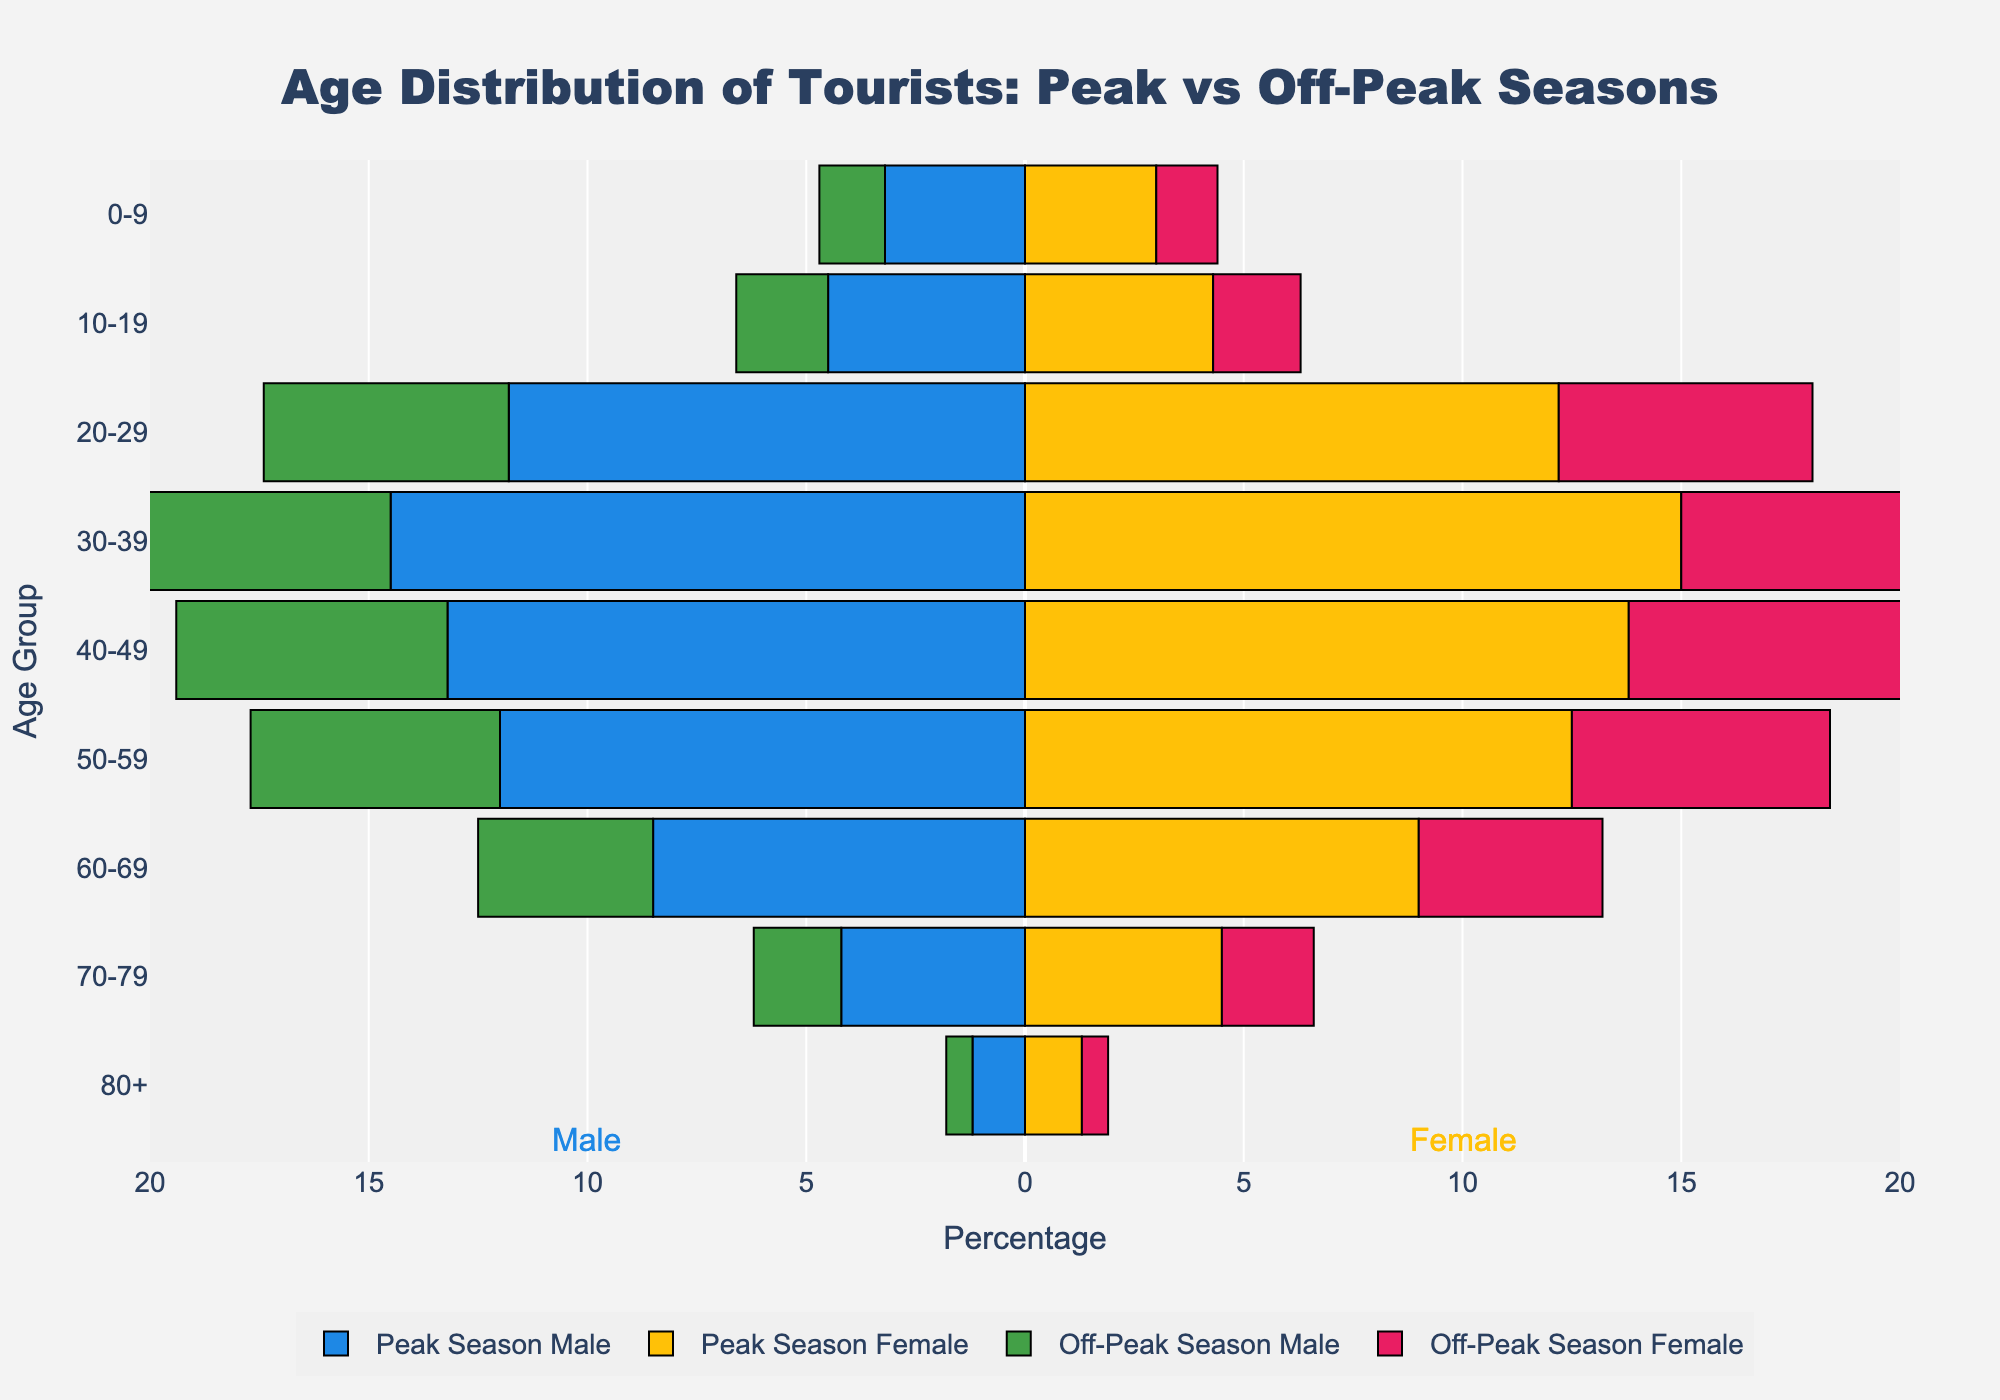What is the title of the figure? The title is usually placed prominently at the top of the figure. In this case, it clearly reads "Age Distribution of Tourists: Peak vs Off-Peak Seasons."
Answer: Age Distribution of Tourists: Peak vs Off-Peak Seasons Which age group has the highest percentage of tourists during the peak season? To find this, compare the lengths of the bars for the peak season across all age groups. Both males and females in the 30-39 age group have the longest bars, indicating the highest percentage.
Answer: 30-39 How does the proportion of 20-29-year-old tourists compare between peak and off-peak seasons for males? Compare the lengths of the bars for the 20-29 age group for males in both peak and off-peak seasons. The peak season bar is significantly longer at 11.8%, while the off-peak season bar is at 5.6%.
Answer: 11.8% (peak) and 5.6% (off-peak) Which gender has a higher percentage of 60-69-year-old tourists during off-peak season? Compare the bar lengths for males and females in the 60-69 age group during the off-peak season. Females at 4.2% have a slightly higher percentage compared to males at 4.0%.
Answer: Females What is the percentage difference in tourists aged 70-79 between peak and off-peak seasons for females? Calculate the percentage difference by subtracting the off-peak percentage from the peak percentage for the 70-79 age group for females: 4.5% (peak) - 2.1% (off-peak) = 2.4%.
Answer: 2.4% In which season and age group do females almost mirror the percentage of their male counterparts' distribution? Look for age groups where the bars for males and females are almost equal in length for a specific season. For the 20-29 age group in both peak and off-peak seasons, the percentages for males and females are quite similar: 11.8% (male) vs. 12.2% (female) in peak and 5.6% (male) vs. 5.8% (female) in off-peak seasons.
Answer: 20-29 in both seasons Which age group shows the largest reduction in percentage for males from peak to off-peak season? Check the differences in bar lengths for males across all age groups from peak to off-peak seasons. The largest reduction is seen in the 30-39 age group where it drops from 14.5% to 6.8%.
Answer: 30-39 On average, do tourists aged 40 and above (both genders) visit more during peak season or off-peak season? Calculate the average percentage for tourists aged 40 and above by considering both peak and off-peak data. For peak: (13.2+13.8+12.0+12.5+8.5+9.0+4.2+4.5+1.2+1.3)/2 = 19.4%. For off-peak: (6.2+6.5+5.7+5.9+4.0+4.2+2.0+2.1+0.6+0.6)/2 = 3.9%. Clearly, tourists aged 40 and above visit more during the peak season.
Answer: Peak season 